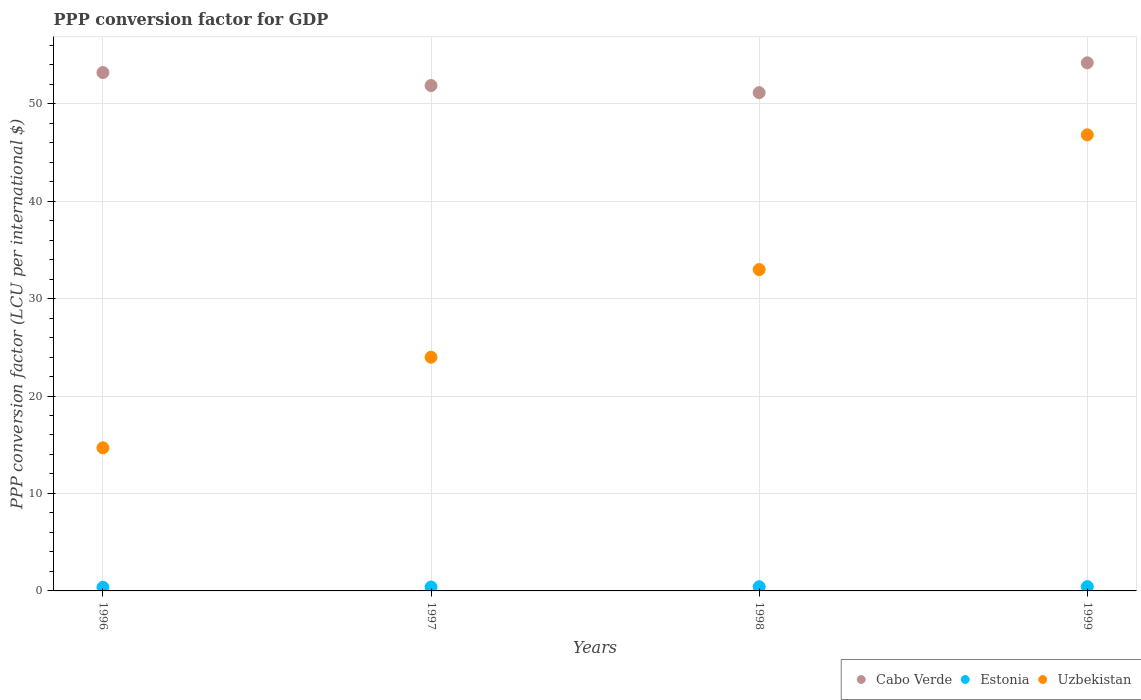What is the PPP conversion factor for GDP in Cabo Verde in 1996?
Your answer should be very brief. 53.19. Across all years, what is the maximum PPP conversion factor for GDP in Estonia?
Make the answer very short. 0.44. Across all years, what is the minimum PPP conversion factor for GDP in Uzbekistan?
Offer a terse response. 14.68. In which year was the PPP conversion factor for GDP in Cabo Verde minimum?
Give a very brief answer. 1998. What is the total PPP conversion factor for GDP in Uzbekistan in the graph?
Give a very brief answer. 118.43. What is the difference between the PPP conversion factor for GDP in Cabo Verde in 1998 and that in 1999?
Offer a terse response. -3.06. What is the difference between the PPP conversion factor for GDP in Uzbekistan in 1998 and the PPP conversion factor for GDP in Estonia in 1996?
Provide a succinct answer. 32.6. What is the average PPP conversion factor for GDP in Uzbekistan per year?
Keep it short and to the point. 29.61. In the year 1996, what is the difference between the PPP conversion factor for GDP in Uzbekistan and PPP conversion factor for GDP in Cabo Verde?
Provide a succinct answer. -38.5. In how many years, is the PPP conversion factor for GDP in Estonia greater than 44 LCU?
Offer a terse response. 0. What is the ratio of the PPP conversion factor for GDP in Cabo Verde in 1996 to that in 1997?
Provide a short and direct response. 1.03. Is the PPP conversion factor for GDP in Estonia in 1996 less than that in 1999?
Offer a terse response. Yes. What is the difference between the highest and the second highest PPP conversion factor for GDP in Uzbekistan?
Make the answer very short. 13.83. What is the difference between the highest and the lowest PPP conversion factor for GDP in Estonia?
Make the answer very short. 0.07. Is the sum of the PPP conversion factor for GDP in Uzbekistan in 1996 and 1999 greater than the maximum PPP conversion factor for GDP in Cabo Verde across all years?
Ensure brevity in your answer.  Yes. Is it the case that in every year, the sum of the PPP conversion factor for GDP in Cabo Verde and PPP conversion factor for GDP in Uzbekistan  is greater than the PPP conversion factor for GDP in Estonia?
Provide a succinct answer. Yes. Is the PPP conversion factor for GDP in Uzbekistan strictly less than the PPP conversion factor for GDP in Cabo Verde over the years?
Offer a very short reply. Yes. How many dotlines are there?
Give a very brief answer. 3. Does the graph contain any zero values?
Keep it short and to the point. No. Does the graph contain grids?
Make the answer very short. Yes. Where does the legend appear in the graph?
Make the answer very short. Bottom right. How many legend labels are there?
Provide a succinct answer. 3. How are the legend labels stacked?
Your response must be concise. Horizontal. What is the title of the graph?
Keep it short and to the point. PPP conversion factor for GDP. Does "Ireland" appear as one of the legend labels in the graph?
Your response must be concise. No. What is the label or title of the Y-axis?
Your answer should be compact. PPP conversion factor (LCU per international $). What is the PPP conversion factor (LCU per international $) in Cabo Verde in 1996?
Give a very brief answer. 53.19. What is the PPP conversion factor (LCU per international $) of Estonia in 1996?
Offer a very short reply. 0.37. What is the PPP conversion factor (LCU per international $) in Uzbekistan in 1996?
Make the answer very short. 14.68. What is the PPP conversion factor (LCU per international $) in Cabo Verde in 1997?
Keep it short and to the point. 51.86. What is the PPP conversion factor (LCU per international $) in Estonia in 1997?
Keep it short and to the point. 0.4. What is the PPP conversion factor (LCU per international $) in Uzbekistan in 1997?
Your answer should be very brief. 23.98. What is the PPP conversion factor (LCU per international $) of Cabo Verde in 1998?
Offer a terse response. 51.13. What is the PPP conversion factor (LCU per international $) in Estonia in 1998?
Offer a very short reply. 0.43. What is the PPP conversion factor (LCU per international $) in Uzbekistan in 1998?
Offer a terse response. 32.97. What is the PPP conversion factor (LCU per international $) of Cabo Verde in 1999?
Your answer should be compact. 54.19. What is the PPP conversion factor (LCU per international $) of Estonia in 1999?
Offer a very short reply. 0.44. What is the PPP conversion factor (LCU per international $) in Uzbekistan in 1999?
Provide a short and direct response. 46.8. Across all years, what is the maximum PPP conversion factor (LCU per international $) of Cabo Verde?
Offer a terse response. 54.19. Across all years, what is the maximum PPP conversion factor (LCU per international $) of Estonia?
Offer a very short reply. 0.44. Across all years, what is the maximum PPP conversion factor (LCU per international $) of Uzbekistan?
Make the answer very short. 46.8. Across all years, what is the minimum PPP conversion factor (LCU per international $) of Cabo Verde?
Ensure brevity in your answer.  51.13. Across all years, what is the minimum PPP conversion factor (LCU per international $) of Estonia?
Keep it short and to the point. 0.37. Across all years, what is the minimum PPP conversion factor (LCU per international $) of Uzbekistan?
Your response must be concise. 14.68. What is the total PPP conversion factor (LCU per international $) of Cabo Verde in the graph?
Keep it short and to the point. 210.36. What is the total PPP conversion factor (LCU per international $) of Estonia in the graph?
Provide a succinct answer. 1.64. What is the total PPP conversion factor (LCU per international $) in Uzbekistan in the graph?
Your response must be concise. 118.43. What is the difference between the PPP conversion factor (LCU per international $) in Cabo Verde in 1996 and that in 1997?
Your response must be concise. 1.33. What is the difference between the PPP conversion factor (LCU per international $) of Estonia in 1996 and that in 1997?
Make the answer very short. -0.03. What is the difference between the PPP conversion factor (LCU per international $) in Uzbekistan in 1996 and that in 1997?
Offer a terse response. -9.29. What is the difference between the PPP conversion factor (LCU per international $) in Cabo Verde in 1996 and that in 1998?
Your response must be concise. 2.06. What is the difference between the PPP conversion factor (LCU per international $) in Estonia in 1996 and that in 1998?
Offer a very short reply. -0.06. What is the difference between the PPP conversion factor (LCU per international $) in Uzbekistan in 1996 and that in 1998?
Provide a succinct answer. -18.29. What is the difference between the PPP conversion factor (LCU per international $) of Cabo Verde in 1996 and that in 1999?
Ensure brevity in your answer.  -1. What is the difference between the PPP conversion factor (LCU per international $) in Estonia in 1996 and that in 1999?
Provide a succinct answer. -0.07. What is the difference between the PPP conversion factor (LCU per international $) in Uzbekistan in 1996 and that in 1999?
Your answer should be compact. -32.11. What is the difference between the PPP conversion factor (LCU per international $) in Cabo Verde in 1997 and that in 1998?
Give a very brief answer. 0.73. What is the difference between the PPP conversion factor (LCU per international $) in Estonia in 1997 and that in 1998?
Your answer should be very brief. -0.03. What is the difference between the PPP conversion factor (LCU per international $) of Uzbekistan in 1997 and that in 1998?
Your answer should be very brief. -8.99. What is the difference between the PPP conversion factor (LCU per international $) in Cabo Verde in 1997 and that in 1999?
Offer a terse response. -2.33. What is the difference between the PPP conversion factor (LCU per international $) of Estonia in 1997 and that in 1999?
Your answer should be compact. -0.04. What is the difference between the PPP conversion factor (LCU per international $) of Uzbekistan in 1997 and that in 1999?
Your answer should be compact. -22.82. What is the difference between the PPP conversion factor (LCU per international $) of Cabo Verde in 1998 and that in 1999?
Your answer should be compact. -3.06. What is the difference between the PPP conversion factor (LCU per international $) in Estonia in 1998 and that in 1999?
Ensure brevity in your answer.  -0.01. What is the difference between the PPP conversion factor (LCU per international $) in Uzbekistan in 1998 and that in 1999?
Keep it short and to the point. -13.83. What is the difference between the PPP conversion factor (LCU per international $) in Cabo Verde in 1996 and the PPP conversion factor (LCU per international $) in Estonia in 1997?
Offer a terse response. 52.79. What is the difference between the PPP conversion factor (LCU per international $) of Cabo Verde in 1996 and the PPP conversion factor (LCU per international $) of Uzbekistan in 1997?
Your answer should be very brief. 29.21. What is the difference between the PPP conversion factor (LCU per international $) in Estonia in 1996 and the PPP conversion factor (LCU per international $) in Uzbekistan in 1997?
Offer a terse response. -23.61. What is the difference between the PPP conversion factor (LCU per international $) in Cabo Verde in 1996 and the PPP conversion factor (LCU per international $) in Estonia in 1998?
Make the answer very short. 52.76. What is the difference between the PPP conversion factor (LCU per international $) in Cabo Verde in 1996 and the PPP conversion factor (LCU per international $) in Uzbekistan in 1998?
Offer a very short reply. 20.22. What is the difference between the PPP conversion factor (LCU per international $) in Estonia in 1996 and the PPP conversion factor (LCU per international $) in Uzbekistan in 1998?
Ensure brevity in your answer.  -32.6. What is the difference between the PPP conversion factor (LCU per international $) of Cabo Verde in 1996 and the PPP conversion factor (LCU per international $) of Estonia in 1999?
Your answer should be compact. 52.74. What is the difference between the PPP conversion factor (LCU per international $) in Cabo Verde in 1996 and the PPP conversion factor (LCU per international $) in Uzbekistan in 1999?
Give a very brief answer. 6.39. What is the difference between the PPP conversion factor (LCU per international $) of Estonia in 1996 and the PPP conversion factor (LCU per international $) of Uzbekistan in 1999?
Offer a terse response. -46.43. What is the difference between the PPP conversion factor (LCU per international $) in Cabo Verde in 1997 and the PPP conversion factor (LCU per international $) in Estonia in 1998?
Give a very brief answer. 51.43. What is the difference between the PPP conversion factor (LCU per international $) in Cabo Verde in 1997 and the PPP conversion factor (LCU per international $) in Uzbekistan in 1998?
Your response must be concise. 18.89. What is the difference between the PPP conversion factor (LCU per international $) of Estonia in 1997 and the PPP conversion factor (LCU per international $) of Uzbekistan in 1998?
Offer a very short reply. -32.57. What is the difference between the PPP conversion factor (LCU per international $) of Cabo Verde in 1997 and the PPP conversion factor (LCU per international $) of Estonia in 1999?
Your response must be concise. 51.41. What is the difference between the PPP conversion factor (LCU per international $) in Cabo Verde in 1997 and the PPP conversion factor (LCU per international $) in Uzbekistan in 1999?
Offer a very short reply. 5.06. What is the difference between the PPP conversion factor (LCU per international $) in Estonia in 1997 and the PPP conversion factor (LCU per international $) in Uzbekistan in 1999?
Ensure brevity in your answer.  -46.4. What is the difference between the PPP conversion factor (LCU per international $) in Cabo Verde in 1998 and the PPP conversion factor (LCU per international $) in Estonia in 1999?
Your answer should be compact. 50.68. What is the difference between the PPP conversion factor (LCU per international $) of Cabo Verde in 1998 and the PPP conversion factor (LCU per international $) of Uzbekistan in 1999?
Offer a terse response. 4.33. What is the difference between the PPP conversion factor (LCU per international $) in Estonia in 1998 and the PPP conversion factor (LCU per international $) in Uzbekistan in 1999?
Provide a short and direct response. -46.37. What is the average PPP conversion factor (LCU per international $) in Cabo Verde per year?
Your answer should be compact. 52.59. What is the average PPP conversion factor (LCU per international $) of Estonia per year?
Give a very brief answer. 0.41. What is the average PPP conversion factor (LCU per international $) in Uzbekistan per year?
Ensure brevity in your answer.  29.61. In the year 1996, what is the difference between the PPP conversion factor (LCU per international $) of Cabo Verde and PPP conversion factor (LCU per international $) of Estonia?
Offer a very short reply. 52.82. In the year 1996, what is the difference between the PPP conversion factor (LCU per international $) in Cabo Verde and PPP conversion factor (LCU per international $) in Uzbekistan?
Your answer should be very brief. 38.5. In the year 1996, what is the difference between the PPP conversion factor (LCU per international $) in Estonia and PPP conversion factor (LCU per international $) in Uzbekistan?
Provide a succinct answer. -14.31. In the year 1997, what is the difference between the PPP conversion factor (LCU per international $) of Cabo Verde and PPP conversion factor (LCU per international $) of Estonia?
Keep it short and to the point. 51.45. In the year 1997, what is the difference between the PPP conversion factor (LCU per international $) in Cabo Verde and PPP conversion factor (LCU per international $) in Uzbekistan?
Ensure brevity in your answer.  27.88. In the year 1997, what is the difference between the PPP conversion factor (LCU per international $) of Estonia and PPP conversion factor (LCU per international $) of Uzbekistan?
Your answer should be compact. -23.58. In the year 1998, what is the difference between the PPP conversion factor (LCU per international $) of Cabo Verde and PPP conversion factor (LCU per international $) of Estonia?
Ensure brevity in your answer.  50.7. In the year 1998, what is the difference between the PPP conversion factor (LCU per international $) in Cabo Verde and PPP conversion factor (LCU per international $) in Uzbekistan?
Keep it short and to the point. 18.16. In the year 1998, what is the difference between the PPP conversion factor (LCU per international $) in Estonia and PPP conversion factor (LCU per international $) in Uzbekistan?
Your answer should be very brief. -32.54. In the year 1999, what is the difference between the PPP conversion factor (LCU per international $) of Cabo Verde and PPP conversion factor (LCU per international $) of Estonia?
Offer a very short reply. 53.74. In the year 1999, what is the difference between the PPP conversion factor (LCU per international $) of Cabo Verde and PPP conversion factor (LCU per international $) of Uzbekistan?
Provide a short and direct response. 7.39. In the year 1999, what is the difference between the PPP conversion factor (LCU per international $) of Estonia and PPP conversion factor (LCU per international $) of Uzbekistan?
Ensure brevity in your answer.  -46.35. What is the ratio of the PPP conversion factor (LCU per international $) of Cabo Verde in 1996 to that in 1997?
Your response must be concise. 1.03. What is the ratio of the PPP conversion factor (LCU per international $) in Estonia in 1996 to that in 1997?
Your answer should be compact. 0.92. What is the ratio of the PPP conversion factor (LCU per international $) of Uzbekistan in 1996 to that in 1997?
Give a very brief answer. 0.61. What is the ratio of the PPP conversion factor (LCU per international $) of Cabo Verde in 1996 to that in 1998?
Your response must be concise. 1.04. What is the ratio of the PPP conversion factor (LCU per international $) in Estonia in 1996 to that in 1998?
Make the answer very short. 0.86. What is the ratio of the PPP conversion factor (LCU per international $) of Uzbekistan in 1996 to that in 1998?
Offer a very short reply. 0.45. What is the ratio of the PPP conversion factor (LCU per international $) in Cabo Verde in 1996 to that in 1999?
Your answer should be compact. 0.98. What is the ratio of the PPP conversion factor (LCU per international $) in Estonia in 1996 to that in 1999?
Your answer should be compact. 0.83. What is the ratio of the PPP conversion factor (LCU per international $) in Uzbekistan in 1996 to that in 1999?
Provide a succinct answer. 0.31. What is the ratio of the PPP conversion factor (LCU per international $) in Cabo Verde in 1997 to that in 1998?
Provide a short and direct response. 1.01. What is the ratio of the PPP conversion factor (LCU per international $) in Estonia in 1997 to that in 1998?
Make the answer very short. 0.93. What is the ratio of the PPP conversion factor (LCU per international $) of Uzbekistan in 1997 to that in 1998?
Ensure brevity in your answer.  0.73. What is the ratio of the PPP conversion factor (LCU per international $) of Cabo Verde in 1997 to that in 1999?
Provide a succinct answer. 0.96. What is the ratio of the PPP conversion factor (LCU per international $) of Estonia in 1997 to that in 1999?
Offer a terse response. 0.9. What is the ratio of the PPP conversion factor (LCU per international $) of Uzbekistan in 1997 to that in 1999?
Provide a succinct answer. 0.51. What is the ratio of the PPP conversion factor (LCU per international $) of Cabo Verde in 1998 to that in 1999?
Offer a terse response. 0.94. What is the ratio of the PPP conversion factor (LCU per international $) in Estonia in 1998 to that in 1999?
Your answer should be compact. 0.97. What is the ratio of the PPP conversion factor (LCU per international $) in Uzbekistan in 1998 to that in 1999?
Your answer should be compact. 0.7. What is the difference between the highest and the second highest PPP conversion factor (LCU per international $) in Cabo Verde?
Offer a very short reply. 1. What is the difference between the highest and the second highest PPP conversion factor (LCU per international $) in Estonia?
Your answer should be compact. 0.01. What is the difference between the highest and the second highest PPP conversion factor (LCU per international $) of Uzbekistan?
Your answer should be compact. 13.83. What is the difference between the highest and the lowest PPP conversion factor (LCU per international $) of Cabo Verde?
Give a very brief answer. 3.06. What is the difference between the highest and the lowest PPP conversion factor (LCU per international $) in Estonia?
Your answer should be compact. 0.07. What is the difference between the highest and the lowest PPP conversion factor (LCU per international $) in Uzbekistan?
Offer a very short reply. 32.11. 